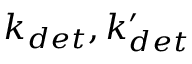Convert formula to latex. <formula><loc_0><loc_0><loc_500><loc_500>k _ { d e t } , k _ { d e t } ^ { \prime }</formula> 